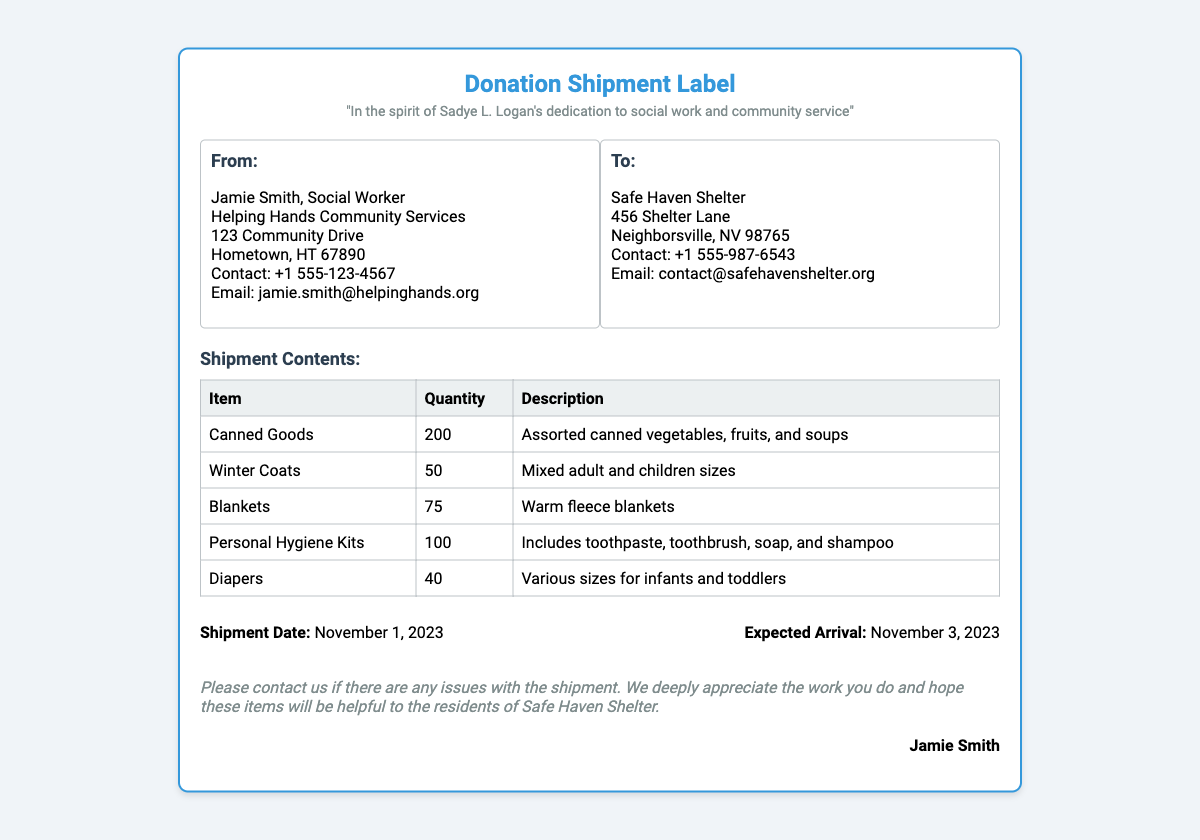What is the name of the sender? The sender's name is listed in the "From:" section of the document.
Answer: Jamie Smith What is the contact number of the Safe Haven Shelter? The contact number for Safe Haven Shelter is provided in the "To:" section of the document.
Answer: +1 555-987-6543 How many winter coats are included in the shipment? The quantity of winter coats is specified in the shipment contents table.
Answer: 50 When is the shipment date? The shipment date is mentioned in the dates section of the document.
Answer: November 1, 2023 What are the contents of the personal hygiene kits? The contents of the personal hygiene kits are described in the shipment details.
Answer: Toothpaste, toothbrush, soap, and shampoo What is the expected arrival date of the shipment? The expected arrival date is provided in the dates section of the document.
Answer: November 3, 2023 Who signed the document? The signature at the end of the document reveals the name of the signer.
Answer: Jamie Smith What kind of items are listed under "Shipment Contents"? The document outlines the types of items being sent in the shipment.
Answer: Canned Goods, Winter Coats, Blankets, Personal Hygiene Kits, Diapers How many personal hygiene kits are included in the shipment? The quantity of personal hygiene kits can be found in the content list.
Answer: 100 